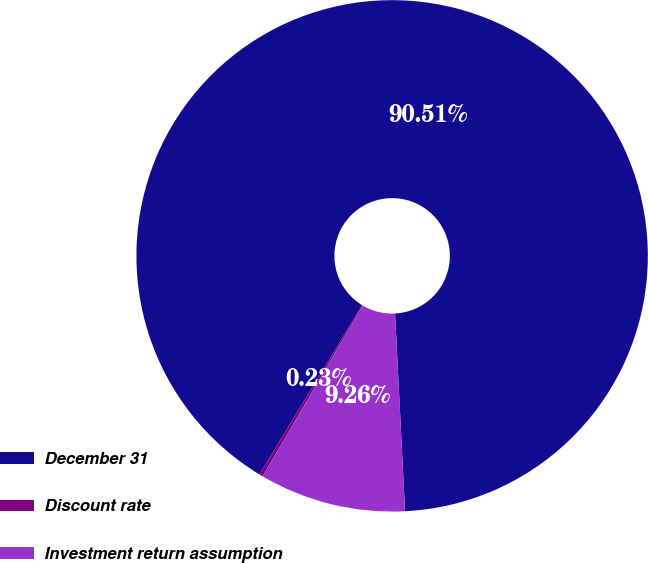Convert chart to OTSL. <chart><loc_0><loc_0><loc_500><loc_500><pie_chart><fcel>December 31<fcel>Discount rate<fcel>Investment return assumption<nl><fcel>90.51%<fcel>0.23%<fcel>9.26%<nl></chart> 